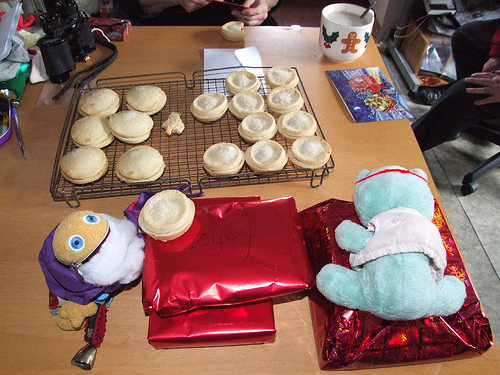<image>
Can you confirm if the cup is on the table? Yes. Looking at the image, I can see the cup is positioned on top of the table, with the table providing support. Is there a present to the left of the present? No. The present is not to the left of the present. From this viewpoint, they have a different horizontal relationship. Where is the table in relation to the tray? Is it in front of the tray? No. The table is not in front of the tray. The spatial positioning shows a different relationship between these objects. 